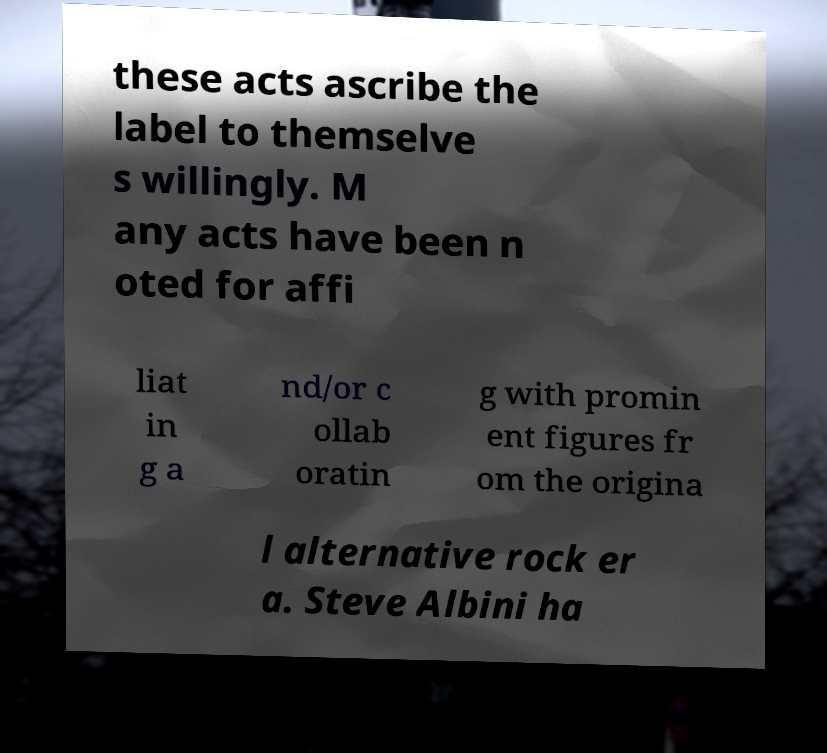What messages or text are displayed in this image? I need them in a readable, typed format. these acts ascribe the label to themselve s willingly. M any acts have been n oted for affi liat in g a nd/or c ollab oratin g with promin ent figures fr om the origina l alternative rock er a. Steve Albini ha 